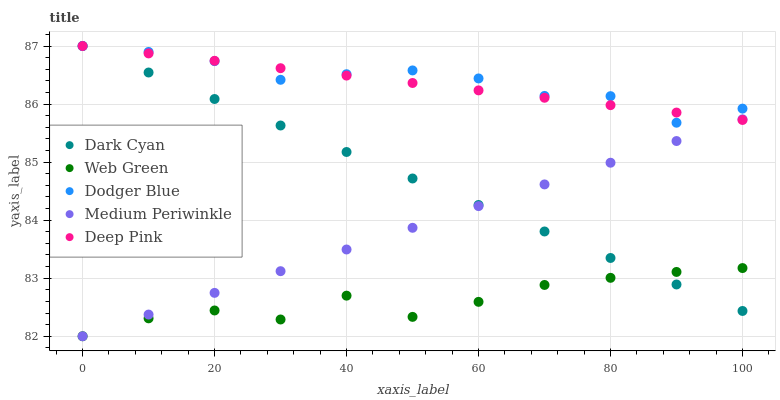Does Web Green have the minimum area under the curve?
Answer yes or no. Yes. Does Dodger Blue have the maximum area under the curve?
Answer yes or no. Yes. Does Medium Periwinkle have the minimum area under the curve?
Answer yes or no. No. Does Medium Periwinkle have the maximum area under the curve?
Answer yes or no. No. Is Medium Periwinkle the smoothest?
Answer yes or no. Yes. Is Web Green the roughest?
Answer yes or no. Yes. Is Deep Pink the smoothest?
Answer yes or no. No. Is Deep Pink the roughest?
Answer yes or no. No. Does Medium Periwinkle have the lowest value?
Answer yes or no. Yes. Does Deep Pink have the lowest value?
Answer yes or no. No. Does Dodger Blue have the highest value?
Answer yes or no. Yes. Does Medium Periwinkle have the highest value?
Answer yes or no. No. Is Web Green less than Deep Pink?
Answer yes or no. Yes. Is Dodger Blue greater than Web Green?
Answer yes or no. Yes. Does Web Green intersect Dark Cyan?
Answer yes or no. Yes. Is Web Green less than Dark Cyan?
Answer yes or no. No. Is Web Green greater than Dark Cyan?
Answer yes or no. No. Does Web Green intersect Deep Pink?
Answer yes or no. No. 